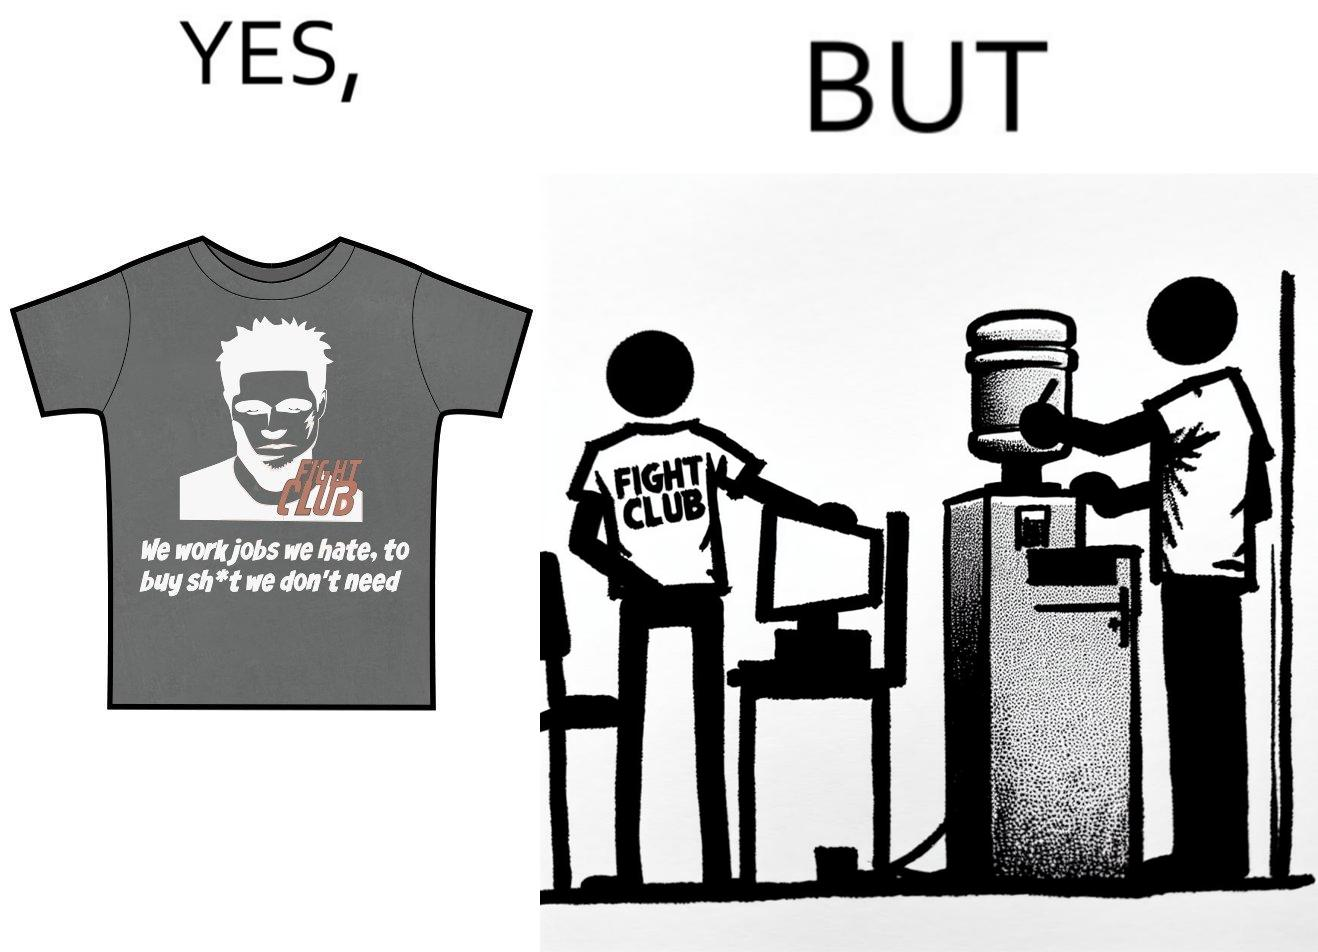Would you classify this image as satirical? Yes, this image is satirical. 